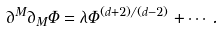Convert formula to latex. <formula><loc_0><loc_0><loc_500><loc_500>\partial ^ { M } \partial _ { M } \Phi = \lambda \Phi ^ { ( d + 2 ) / ( d - 2 ) } + \cdots .</formula> 